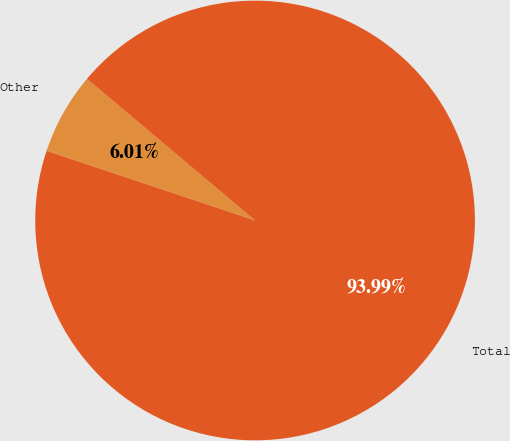Convert chart to OTSL. <chart><loc_0><loc_0><loc_500><loc_500><pie_chart><fcel>Other<fcel>Total<nl><fcel>6.01%<fcel>93.99%<nl></chart> 